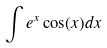Convert formula to latex. <formula><loc_0><loc_0><loc_500><loc_500>\int e ^ { x } \cos ( x ) d x</formula> 